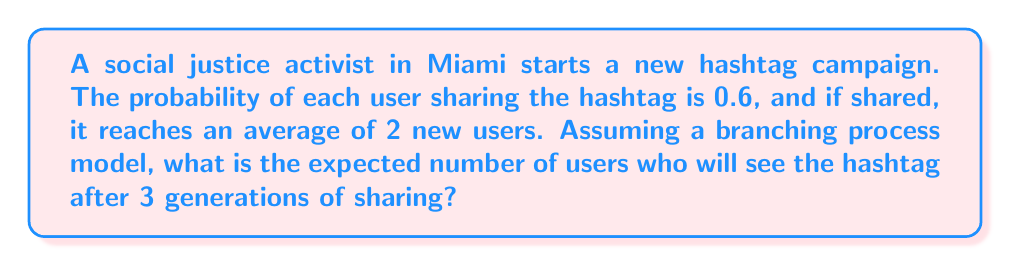Provide a solution to this math problem. Let's approach this step-by-step using a branching process model:

1) First, we need to calculate the expected number of offspring (shares) per individual:
   $\mu = 0.6 \times 2 = 1.2$

2) In a branching process, the expected number of individuals in the nth generation is given by:
   $E[X_n] = \mu^n$

3) We want to find the total number of users who will see the hashtag after 3 generations. This includes the initial user and all subsequent generations. We can calculate this as follows:

   $\text{Total} = 1 + E[X_1] + E[X_2] + E[X_3]$

4) Let's calculate each term:
   $E[X_1] = \mu^1 = 1.2$
   $E[X_2] = \mu^2 = 1.2^2 = 1.44$
   $E[X_3] = \mu^3 = 1.2^3 = 1.728$

5) Now, we can sum up:
   $\text{Total} = 1 + 1.2 + 1.44 + 1.728 = 5.368$

Therefore, the expected number of users who will see the hashtag after 3 generations of sharing is approximately 5.37.
Answer: 5.37 users 